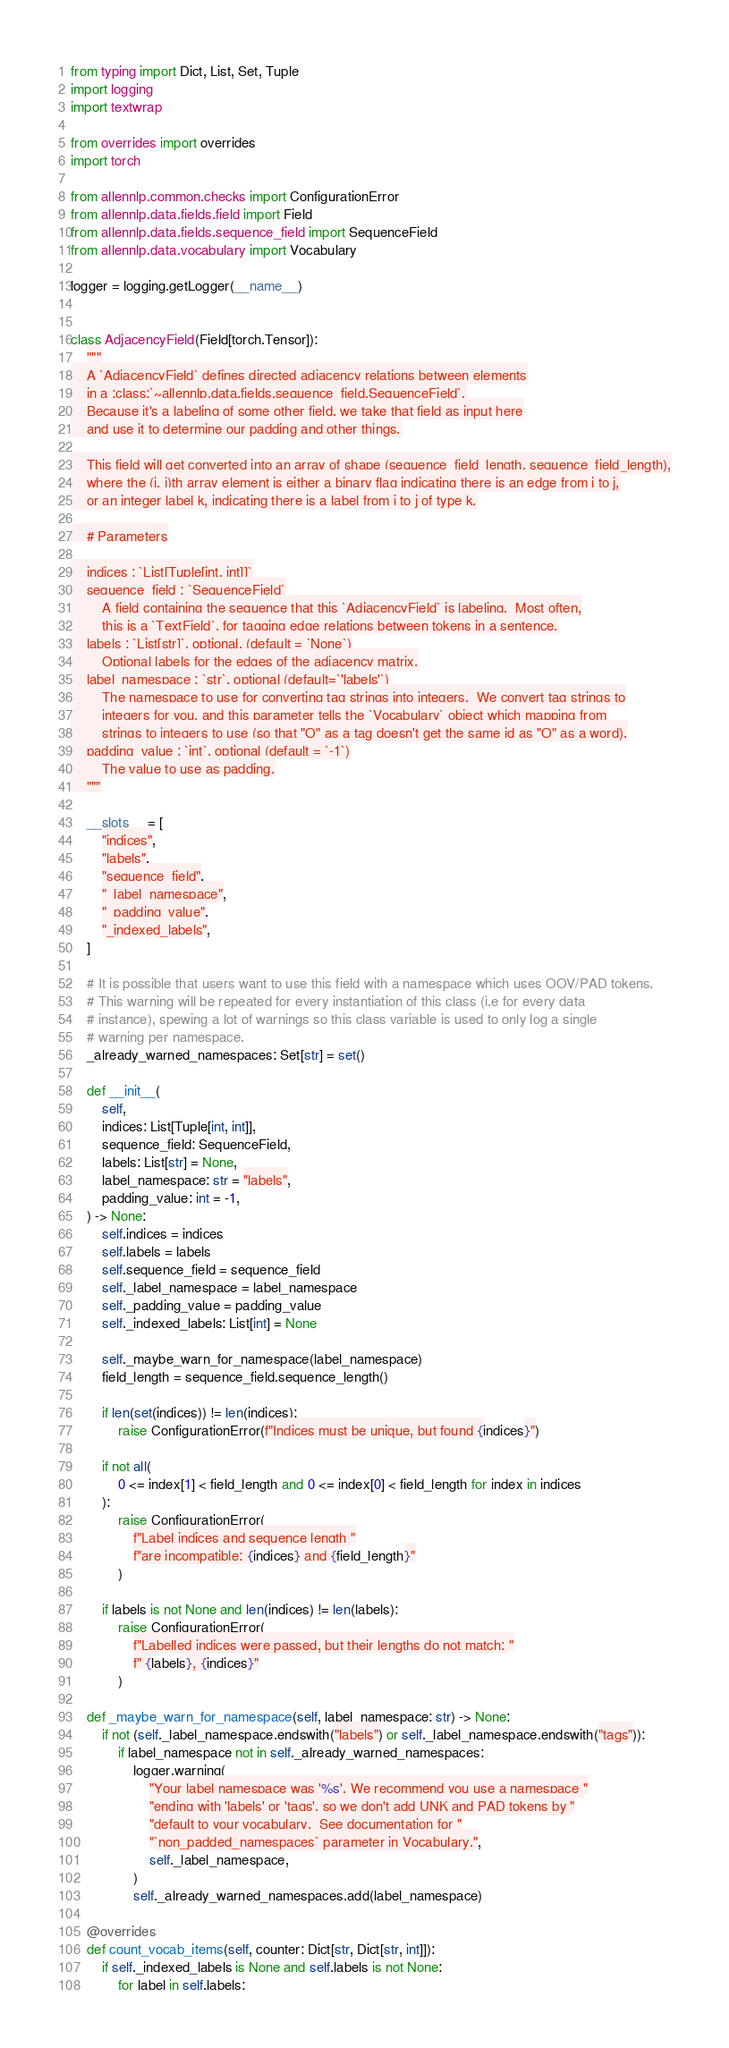<code> <loc_0><loc_0><loc_500><loc_500><_Python_>from typing import Dict, List, Set, Tuple
import logging
import textwrap

from overrides import overrides
import torch

from allennlp.common.checks import ConfigurationError
from allennlp.data.fields.field import Field
from allennlp.data.fields.sequence_field import SequenceField
from allennlp.data.vocabulary import Vocabulary

logger = logging.getLogger(__name__)


class AdjacencyField(Field[torch.Tensor]):
    """
    A `AdjacencyField` defines directed adjacency relations between elements
    in a :class:`~allennlp.data.fields.sequence_field.SequenceField`.
    Because it's a labeling of some other field, we take that field as input here
    and use it to determine our padding and other things.

    This field will get converted into an array of shape (sequence_field_length, sequence_field_length),
    where the (i, j)th array element is either a binary flag indicating there is an edge from i to j,
    or an integer label k, indicating there is a label from i to j of type k.

    # Parameters

    indices : `List[Tuple[int, int]]`
    sequence_field : `SequenceField`
        A field containing the sequence that this `AdjacencyField` is labeling.  Most often,
        this is a `TextField`, for tagging edge relations between tokens in a sentence.
    labels : `List[str]`, optional, (default = `None`)
        Optional labels for the edges of the adjacency matrix.
    label_namespace : `str`, optional (default=`'labels'`)
        The namespace to use for converting tag strings into integers.  We convert tag strings to
        integers for you, and this parameter tells the `Vocabulary` object which mapping from
        strings to integers to use (so that "O" as a tag doesn't get the same id as "O" as a word).
    padding_value : `int`, optional (default = `-1`)
        The value to use as padding.
    """

    __slots__ = [
        "indices",
        "labels",
        "sequence_field",
        "_label_namespace",
        "_padding_value",
        "_indexed_labels",
    ]

    # It is possible that users want to use this field with a namespace which uses OOV/PAD tokens.
    # This warning will be repeated for every instantiation of this class (i.e for every data
    # instance), spewing a lot of warnings so this class variable is used to only log a single
    # warning per namespace.
    _already_warned_namespaces: Set[str] = set()

    def __init__(
        self,
        indices: List[Tuple[int, int]],
        sequence_field: SequenceField,
        labels: List[str] = None,
        label_namespace: str = "labels",
        padding_value: int = -1,
    ) -> None:
        self.indices = indices
        self.labels = labels
        self.sequence_field = sequence_field
        self._label_namespace = label_namespace
        self._padding_value = padding_value
        self._indexed_labels: List[int] = None

        self._maybe_warn_for_namespace(label_namespace)
        field_length = sequence_field.sequence_length()

        if len(set(indices)) != len(indices):
            raise ConfigurationError(f"Indices must be unique, but found {indices}")

        if not all(
            0 <= index[1] < field_length and 0 <= index[0] < field_length for index in indices
        ):
            raise ConfigurationError(
                f"Label indices and sequence length "
                f"are incompatible: {indices} and {field_length}"
            )

        if labels is not None and len(indices) != len(labels):
            raise ConfigurationError(
                f"Labelled indices were passed, but their lengths do not match: "
                f" {labels}, {indices}"
            )

    def _maybe_warn_for_namespace(self, label_namespace: str) -> None:
        if not (self._label_namespace.endswith("labels") or self._label_namespace.endswith("tags")):
            if label_namespace not in self._already_warned_namespaces:
                logger.warning(
                    "Your label namespace was '%s'. We recommend you use a namespace "
                    "ending with 'labels' or 'tags', so we don't add UNK and PAD tokens by "
                    "default to your vocabulary.  See documentation for "
                    "`non_padded_namespaces` parameter in Vocabulary.",
                    self._label_namespace,
                )
                self._already_warned_namespaces.add(label_namespace)

    @overrides
    def count_vocab_items(self, counter: Dict[str, Dict[str, int]]):
        if self._indexed_labels is None and self.labels is not None:
            for label in self.labels:</code> 